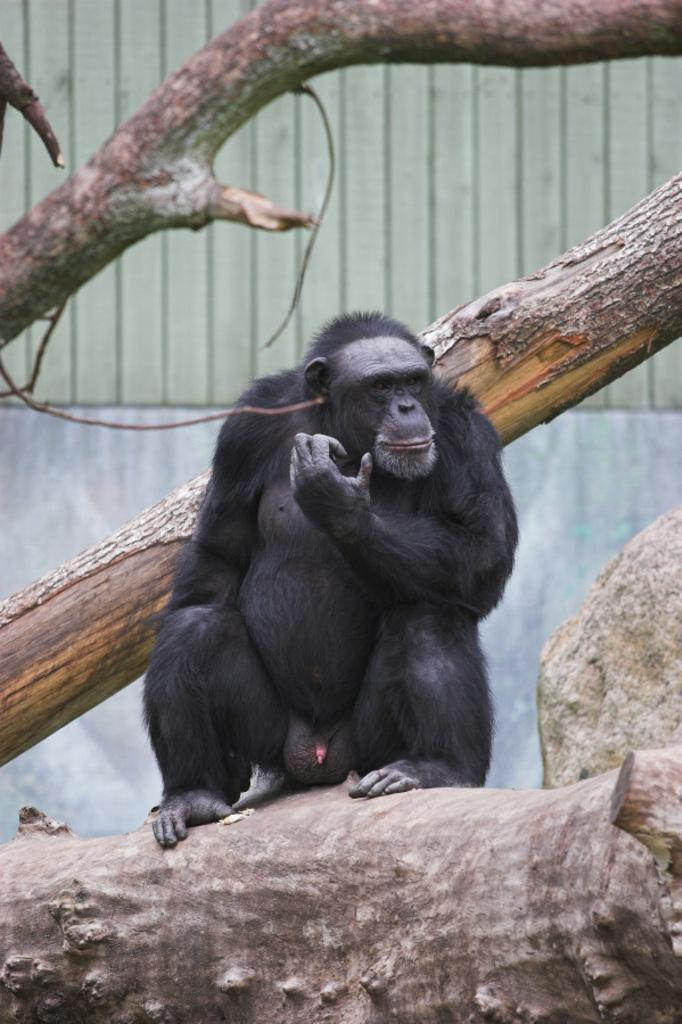What animal is the main subject of the image? There is a chimpanzee in the image. Where is the chimpanzee sitting? The chimpanzee is sitting on a tree trunk. What can be seen in the background of the image? There are tree branches and a wall visible in the background of the image. How does the chimpanzee show respect to the island in the image? There is no island present in the image, and therefore no opportunity for the chimpanzee to show respect to it. 